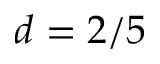<formula> <loc_0><loc_0><loc_500><loc_500>d = 2 / 5</formula> 